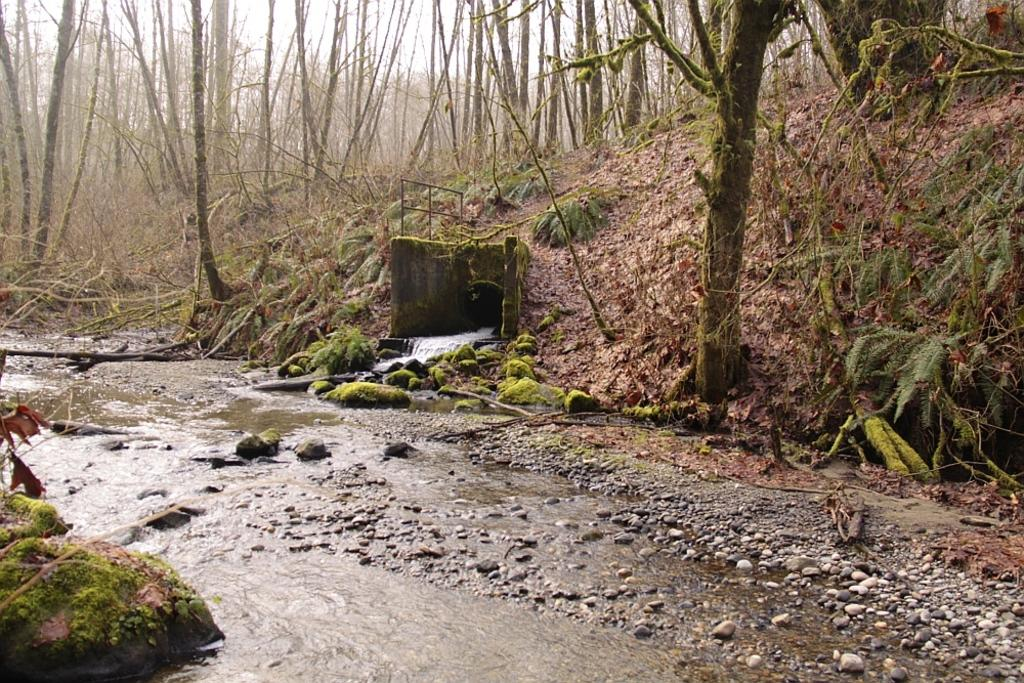What type of vegetation can be seen in the image? There are trees in the image. What natural element is present and in motion? There is water flowing in the image. What type of ground cover is visible in the image? There is grass in the image. What type of solid material is present in the image? There are stones in the image. How long does it take for the trees to offer their experience in the image? There is no indication in the image that the trees are offering any experience, and therefore the question cannot be answered. 